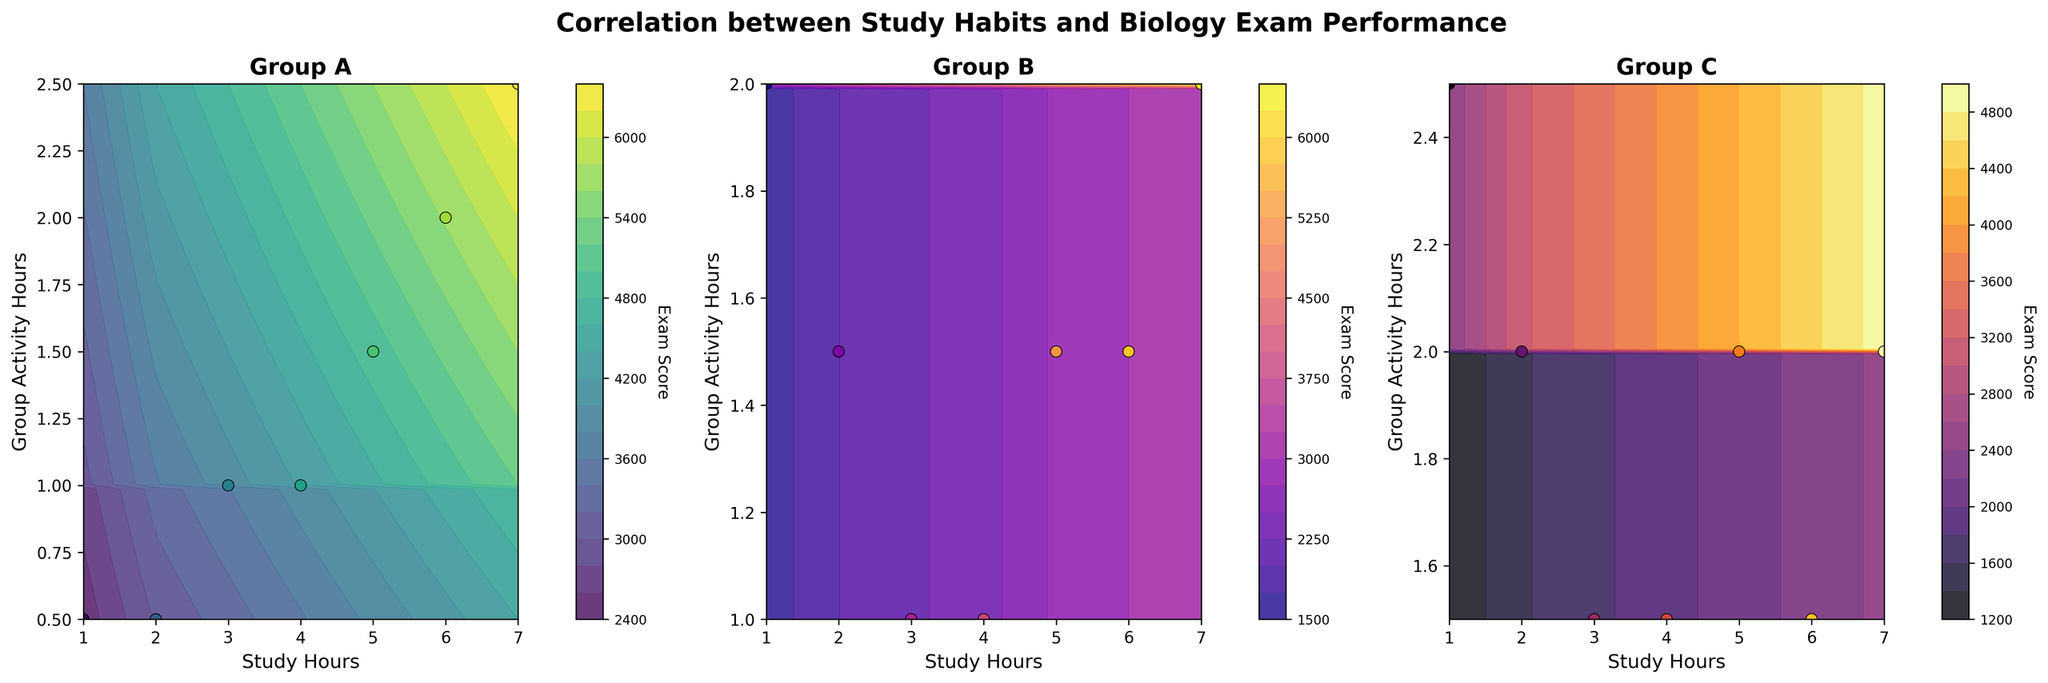What's the title of the figure? The title is displayed at the top of the figure, "Correlation between Study Habits and Biology Exam Performance" with font size 16 and fontweight bold.
Answer: Correlation between Study Habits and Biology Exam Performance What are the labeled x-axes and y-axes? Each subplot has labels for its x-axis and y-axis. The x-axis is labeled “Study Hours" and the y-axis is labeled "Group Activity Hours".
Answer: Study Hours, Group Activity Hours Which group shows the highest exam score in the contour plots? By observing the color gradients and color bars next to each subplot. Group A shows the highest exam score as indicated by the darkest color in its contour plot.
Answer: Group A What color maps are used for each group? The color maps used are viridis (Group A), plasma (Group B), and inferno (Group C), as indicated by the colors filling the contours.
Answer: viridis, plasma, inferno How does the relationship between study hours and exam scores differ among the groups? Comparing the gradients of exam scores in each subplot, Group A shows a significant increase in exam scores with more study hours. Group B and C also show a general increase but with varying levels of group activity hours.
Answer: Group A shows the steepest increase How do the group activity hours affect exam scores for Groups B and C? Observing the contours, Group B's exam scores are higher at slightly lower activity hours, while Group C shows higher scores with slightly higher activity hours.
Answer: Lower for Group B, slightly higher for Group C In which subplot does group activity hours have the least apparent effect on exam scores? By examining the contour density and spread, Group A shows the least effect of group activity hours on exam scores since the gradient changes more significantly with study hours.
Answer: Group A Which subplot contains data points with the smallest range of study hours, and what is that range? By looking at the scatter plots, Group A has data points from 1 to 7 study hours, which is the same for all groups.
Answer: All groups have the same range, 1 to 7 study hours What trends can you observe in how group activity hours and study hours correlate with exam scores for Group C? The contour plot and scatter points show that higher study hours and a narrow range of group activity hours result in increased exam scores. Exam scores in Group C increase with stable group activity hours around 2.
Answer: Higher scores with stable higher group activity hours around 2 